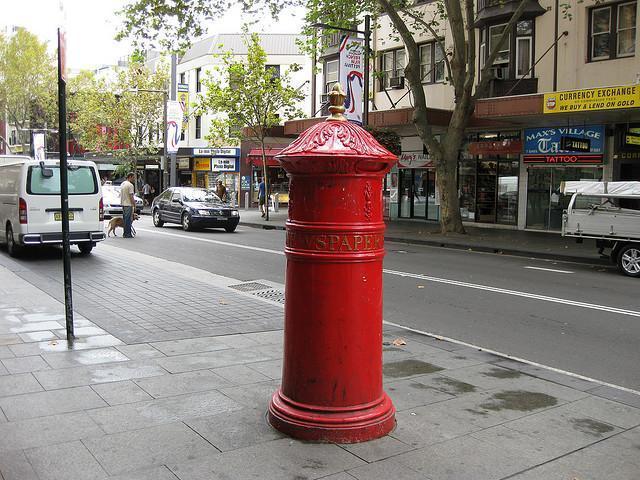How many cars are visible?
Give a very brief answer. 1. How many trucks are there?
Give a very brief answer. 2. 